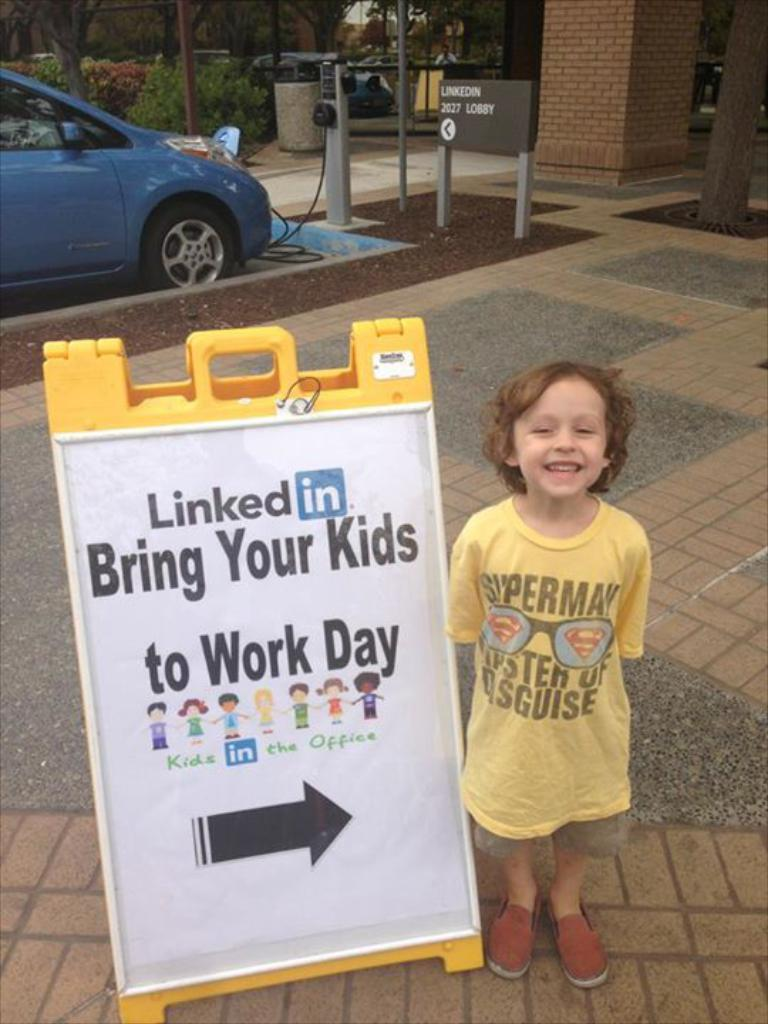What is the main subject of the image? The main subject of the image is a kid. What is the kid doing in the image? The kid is standing beside a board. What can be seen on the board? There is text on the board. What can be seen in the background of the image? There is a car, trees, and a pillar in the background of the image. What type of stove is visible in the image? There is no stove present in the image. How does the girl interact with the text on the board in the image? There is no girl present in the image; it features a kid standing beside the board. 